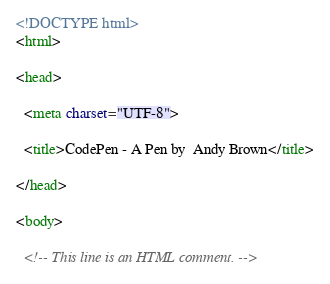Convert code to text. <code><loc_0><loc_0><loc_500><loc_500><_HTML_><!DOCTYPE html>
<html>

<head>

  <meta charset="UTF-8">

  <title>CodePen - A Pen by  Andy Brown</title>

</head>

<body>

  <!-- This line is an HTML comment. --></code> 